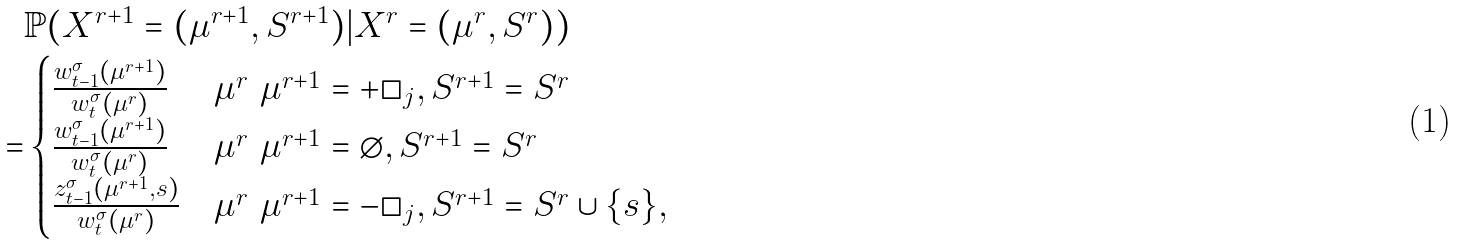Convert formula to latex. <formula><loc_0><loc_0><loc_500><loc_500>& \mathbb { P } ( X ^ { r + 1 } = ( \mu ^ { r + 1 } , S ^ { r + 1 } ) | X ^ { r } = ( \mu ^ { r } , S ^ { r } ) ) \\ = & \begin{cases} \frac { w ^ { \sigma } _ { t - 1 } ( \mu ^ { r + 1 } ) } { w ^ { \sigma } _ { t } ( \mu ^ { r } ) } & \mu ^ { r } \ \mu ^ { r + 1 } = + \square _ { j } , S ^ { r + 1 } = S ^ { r } \\ \frac { w ^ { \sigma } _ { t - 1 } ( \mu ^ { r + 1 } ) } { w ^ { \sigma } _ { t } ( \mu ^ { r } ) } & \mu ^ { r } \ \mu ^ { r + 1 } = \varnothing , S ^ { r + 1 } = S ^ { r } \\ \frac { z ^ { \sigma } _ { t - 1 } ( \mu ^ { r + 1 } , s ) } { w ^ { \sigma } _ { t } ( \mu ^ { r } ) } & \mu ^ { r } \ \mu ^ { r + 1 } = - \square _ { j } , S ^ { r + 1 } = S ^ { r } \cup \{ s \} , \end{cases}</formula> 